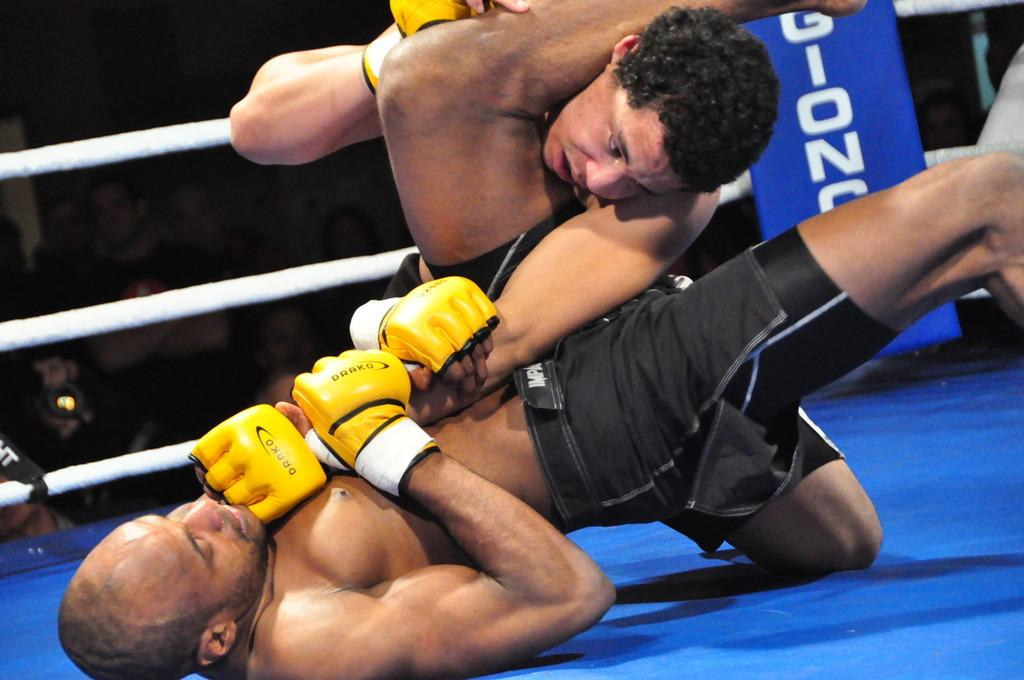<image>
Give a short and clear explanation of the subsequent image. men wrestle in an arena with the letters Gion on it 